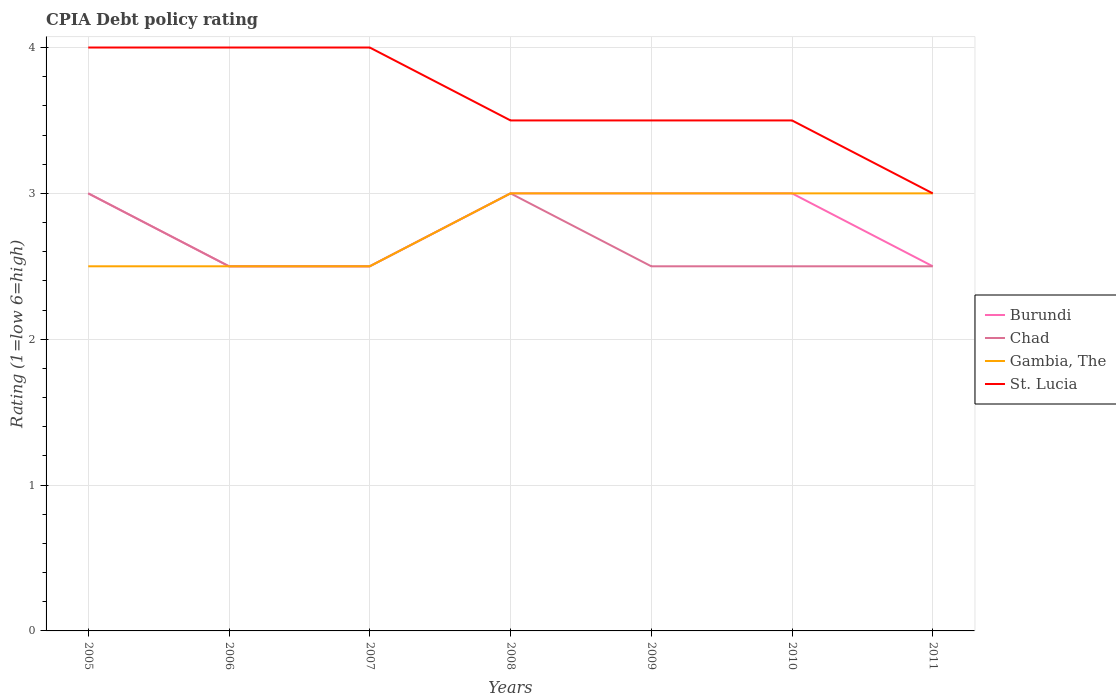How many different coloured lines are there?
Provide a short and direct response. 4. Across all years, what is the maximum CPIA rating in St. Lucia?
Provide a succinct answer. 3. What is the total CPIA rating in Gambia, The in the graph?
Offer a terse response. 0. What is the difference between the highest and the second highest CPIA rating in Burundi?
Your answer should be very brief. 0.5. How many lines are there?
Your response must be concise. 4. How many years are there in the graph?
Provide a succinct answer. 7. Are the values on the major ticks of Y-axis written in scientific E-notation?
Ensure brevity in your answer.  No. Does the graph contain any zero values?
Provide a short and direct response. No. Does the graph contain grids?
Give a very brief answer. Yes. Where does the legend appear in the graph?
Your answer should be compact. Center right. What is the title of the graph?
Give a very brief answer. CPIA Debt policy rating. Does "Cabo Verde" appear as one of the legend labels in the graph?
Provide a succinct answer. No. What is the label or title of the X-axis?
Your answer should be very brief. Years. What is the label or title of the Y-axis?
Offer a terse response. Rating (1=low 6=high). What is the Rating (1=low 6=high) in Burundi in 2005?
Offer a very short reply. 3. What is the Rating (1=low 6=high) in Gambia, The in 2005?
Offer a terse response. 2.5. What is the Rating (1=low 6=high) of Gambia, The in 2006?
Make the answer very short. 2.5. What is the Rating (1=low 6=high) of St. Lucia in 2006?
Offer a terse response. 4. What is the Rating (1=low 6=high) in Burundi in 2007?
Keep it short and to the point. 2.5. What is the Rating (1=low 6=high) in Burundi in 2008?
Offer a terse response. 3. What is the Rating (1=low 6=high) in Chad in 2008?
Ensure brevity in your answer.  3. What is the Rating (1=low 6=high) in Gambia, The in 2008?
Make the answer very short. 3. What is the Rating (1=low 6=high) of Chad in 2009?
Offer a terse response. 2.5. What is the Rating (1=low 6=high) in St. Lucia in 2009?
Offer a very short reply. 3.5. What is the Rating (1=low 6=high) of Burundi in 2010?
Keep it short and to the point. 3. What is the Rating (1=low 6=high) of Chad in 2010?
Your answer should be very brief. 2.5. What is the Rating (1=low 6=high) in Chad in 2011?
Give a very brief answer. 2.5. What is the Rating (1=low 6=high) in St. Lucia in 2011?
Keep it short and to the point. 3. Across all years, what is the maximum Rating (1=low 6=high) in Burundi?
Keep it short and to the point. 3. Across all years, what is the maximum Rating (1=low 6=high) of Gambia, The?
Keep it short and to the point. 3. Across all years, what is the minimum Rating (1=low 6=high) in Burundi?
Keep it short and to the point. 2.5. Across all years, what is the minimum Rating (1=low 6=high) of Chad?
Keep it short and to the point. 2.5. Across all years, what is the minimum Rating (1=low 6=high) in Gambia, The?
Your answer should be compact. 2.5. Across all years, what is the minimum Rating (1=low 6=high) of St. Lucia?
Ensure brevity in your answer.  3. What is the total Rating (1=low 6=high) in Chad in the graph?
Offer a very short reply. 18.5. What is the total Rating (1=low 6=high) of St. Lucia in the graph?
Your answer should be very brief. 25.5. What is the difference between the Rating (1=low 6=high) in St. Lucia in 2005 and that in 2006?
Ensure brevity in your answer.  0. What is the difference between the Rating (1=low 6=high) in Burundi in 2005 and that in 2007?
Give a very brief answer. 0.5. What is the difference between the Rating (1=low 6=high) in Chad in 2005 and that in 2007?
Keep it short and to the point. 0.5. What is the difference between the Rating (1=low 6=high) of Gambia, The in 2005 and that in 2007?
Your answer should be very brief. 0. What is the difference between the Rating (1=low 6=high) in Burundi in 2005 and that in 2008?
Provide a short and direct response. 0. What is the difference between the Rating (1=low 6=high) of Burundi in 2005 and that in 2009?
Your answer should be compact. 0. What is the difference between the Rating (1=low 6=high) in Gambia, The in 2005 and that in 2009?
Keep it short and to the point. -0.5. What is the difference between the Rating (1=low 6=high) in St. Lucia in 2005 and that in 2009?
Ensure brevity in your answer.  0.5. What is the difference between the Rating (1=low 6=high) of Chad in 2005 and that in 2010?
Provide a short and direct response. 0.5. What is the difference between the Rating (1=low 6=high) of Gambia, The in 2005 and that in 2011?
Provide a short and direct response. -0.5. What is the difference between the Rating (1=low 6=high) in St. Lucia in 2005 and that in 2011?
Keep it short and to the point. 1. What is the difference between the Rating (1=low 6=high) of Burundi in 2006 and that in 2007?
Offer a very short reply. 0. What is the difference between the Rating (1=low 6=high) of Gambia, The in 2006 and that in 2007?
Keep it short and to the point. 0. What is the difference between the Rating (1=low 6=high) in St. Lucia in 2006 and that in 2007?
Make the answer very short. 0. What is the difference between the Rating (1=low 6=high) of Burundi in 2006 and that in 2008?
Provide a succinct answer. -0.5. What is the difference between the Rating (1=low 6=high) in Gambia, The in 2006 and that in 2008?
Your answer should be compact. -0.5. What is the difference between the Rating (1=low 6=high) of St. Lucia in 2006 and that in 2008?
Keep it short and to the point. 0.5. What is the difference between the Rating (1=low 6=high) in Burundi in 2006 and that in 2009?
Provide a short and direct response. -0.5. What is the difference between the Rating (1=low 6=high) in Chad in 2006 and that in 2009?
Make the answer very short. 0. What is the difference between the Rating (1=low 6=high) in Gambia, The in 2006 and that in 2009?
Your response must be concise. -0.5. What is the difference between the Rating (1=low 6=high) of St. Lucia in 2006 and that in 2009?
Provide a short and direct response. 0.5. What is the difference between the Rating (1=low 6=high) of Chad in 2006 and that in 2010?
Provide a short and direct response. 0. What is the difference between the Rating (1=low 6=high) of Gambia, The in 2006 and that in 2010?
Your answer should be very brief. -0.5. What is the difference between the Rating (1=low 6=high) in Burundi in 2006 and that in 2011?
Offer a terse response. 0. What is the difference between the Rating (1=low 6=high) in St. Lucia in 2006 and that in 2011?
Make the answer very short. 1. What is the difference between the Rating (1=low 6=high) of Burundi in 2007 and that in 2008?
Provide a succinct answer. -0.5. What is the difference between the Rating (1=low 6=high) in Chad in 2007 and that in 2008?
Give a very brief answer. -0.5. What is the difference between the Rating (1=low 6=high) in Gambia, The in 2007 and that in 2008?
Offer a very short reply. -0.5. What is the difference between the Rating (1=low 6=high) in Burundi in 2007 and that in 2009?
Keep it short and to the point. -0.5. What is the difference between the Rating (1=low 6=high) of Chad in 2007 and that in 2009?
Keep it short and to the point. 0. What is the difference between the Rating (1=low 6=high) of Gambia, The in 2007 and that in 2009?
Keep it short and to the point. -0.5. What is the difference between the Rating (1=low 6=high) in Chad in 2007 and that in 2010?
Make the answer very short. 0. What is the difference between the Rating (1=low 6=high) in St. Lucia in 2007 and that in 2010?
Provide a short and direct response. 0.5. What is the difference between the Rating (1=low 6=high) of Burundi in 2007 and that in 2011?
Your answer should be very brief. 0. What is the difference between the Rating (1=low 6=high) of Gambia, The in 2007 and that in 2011?
Offer a very short reply. -0.5. What is the difference between the Rating (1=low 6=high) in St. Lucia in 2007 and that in 2011?
Your answer should be compact. 1. What is the difference between the Rating (1=low 6=high) of Burundi in 2008 and that in 2009?
Ensure brevity in your answer.  0. What is the difference between the Rating (1=low 6=high) in Chad in 2008 and that in 2009?
Give a very brief answer. 0.5. What is the difference between the Rating (1=low 6=high) of St. Lucia in 2008 and that in 2009?
Offer a terse response. 0. What is the difference between the Rating (1=low 6=high) of Burundi in 2008 and that in 2010?
Offer a very short reply. 0. What is the difference between the Rating (1=low 6=high) in Gambia, The in 2008 and that in 2010?
Your response must be concise. 0. What is the difference between the Rating (1=low 6=high) of St. Lucia in 2008 and that in 2010?
Offer a terse response. 0. What is the difference between the Rating (1=low 6=high) in Burundi in 2008 and that in 2011?
Provide a short and direct response. 0.5. What is the difference between the Rating (1=low 6=high) in Chad in 2008 and that in 2011?
Give a very brief answer. 0.5. What is the difference between the Rating (1=low 6=high) of Gambia, The in 2008 and that in 2011?
Provide a succinct answer. 0. What is the difference between the Rating (1=low 6=high) in St. Lucia in 2008 and that in 2011?
Give a very brief answer. 0.5. What is the difference between the Rating (1=low 6=high) of Chad in 2009 and that in 2010?
Provide a succinct answer. 0. What is the difference between the Rating (1=low 6=high) of St. Lucia in 2009 and that in 2010?
Give a very brief answer. 0. What is the difference between the Rating (1=low 6=high) of Chad in 2009 and that in 2011?
Give a very brief answer. 0. What is the difference between the Rating (1=low 6=high) in Chad in 2010 and that in 2011?
Ensure brevity in your answer.  0. What is the difference between the Rating (1=low 6=high) of Gambia, The in 2010 and that in 2011?
Keep it short and to the point. 0. What is the difference between the Rating (1=low 6=high) of Burundi in 2005 and the Rating (1=low 6=high) of Gambia, The in 2006?
Provide a short and direct response. 0.5. What is the difference between the Rating (1=low 6=high) in Burundi in 2005 and the Rating (1=low 6=high) in St. Lucia in 2006?
Make the answer very short. -1. What is the difference between the Rating (1=low 6=high) of Chad in 2005 and the Rating (1=low 6=high) of Gambia, The in 2006?
Give a very brief answer. 0.5. What is the difference between the Rating (1=low 6=high) in Chad in 2005 and the Rating (1=low 6=high) in St. Lucia in 2006?
Your response must be concise. -1. What is the difference between the Rating (1=low 6=high) of Burundi in 2005 and the Rating (1=low 6=high) of Chad in 2007?
Your answer should be very brief. 0.5. What is the difference between the Rating (1=low 6=high) in Burundi in 2005 and the Rating (1=low 6=high) in Gambia, The in 2007?
Ensure brevity in your answer.  0.5. What is the difference between the Rating (1=low 6=high) of Burundi in 2005 and the Rating (1=low 6=high) of St. Lucia in 2007?
Keep it short and to the point. -1. What is the difference between the Rating (1=low 6=high) in Chad in 2005 and the Rating (1=low 6=high) in St. Lucia in 2007?
Your answer should be compact. -1. What is the difference between the Rating (1=low 6=high) of Gambia, The in 2005 and the Rating (1=low 6=high) of St. Lucia in 2007?
Your response must be concise. -1.5. What is the difference between the Rating (1=low 6=high) in Burundi in 2005 and the Rating (1=low 6=high) in Gambia, The in 2008?
Offer a very short reply. 0. What is the difference between the Rating (1=low 6=high) in Burundi in 2005 and the Rating (1=low 6=high) in St. Lucia in 2008?
Keep it short and to the point. -0.5. What is the difference between the Rating (1=low 6=high) of Gambia, The in 2005 and the Rating (1=low 6=high) of St. Lucia in 2008?
Give a very brief answer. -1. What is the difference between the Rating (1=low 6=high) in Burundi in 2005 and the Rating (1=low 6=high) in Chad in 2009?
Ensure brevity in your answer.  0.5. What is the difference between the Rating (1=low 6=high) of Burundi in 2005 and the Rating (1=low 6=high) of St. Lucia in 2009?
Offer a very short reply. -0.5. What is the difference between the Rating (1=low 6=high) of Chad in 2005 and the Rating (1=low 6=high) of Gambia, The in 2009?
Your answer should be very brief. 0. What is the difference between the Rating (1=low 6=high) of Chad in 2005 and the Rating (1=low 6=high) of St. Lucia in 2009?
Your answer should be compact. -0.5. What is the difference between the Rating (1=low 6=high) of Burundi in 2005 and the Rating (1=low 6=high) of Chad in 2010?
Keep it short and to the point. 0.5. What is the difference between the Rating (1=low 6=high) of Burundi in 2006 and the Rating (1=low 6=high) of Chad in 2007?
Provide a succinct answer. 0. What is the difference between the Rating (1=low 6=high) of Burundi in 2006 and the Rating (1=low 6=high) of Chad in 2008?
Provide a succinct answer. -0.5. What is the difference between the Rating (1=low 6=high) of Burundi in 2006 and the Rating (1=low 6=high) of Gambia, The in 2008?
Your response must be concise. -0.5. What is the difference between the Rating (1=low 6=high) of Chad in 2006 and the Rating (1=low 6=high) of St. Lucia in 2008?
Make the answer very short. -1. What is the difference between the Rating (1=low 6=high) of Gambia, The in 2006 and the Rating (1=low 6=high) of St. Lucia in 2008?
Provide a succinct answer. -1. What is the difference between the Rating (1=low 6=high) in Burundi in 2006 and the Rating (1=low 6=high) in Gambia, The in 2009?
Provide a succinct answer. -0.5. What is the difference between the Rating (1=low 6=high) in Chad in 2006 and the Rating (1=low 6=high) in Gambia, The in 2009?
Your answer should be compact. -0.5. What is the difference between the Rating (1=low 6=high) in Chad in 2006 and the Rating (1=low 6=high) in St. Lucia in 2010?
Make the answer very short. -1. What is the difference between the Rating (1=low 6=high) of Gambia, The in 2006 and the Rating (1=low 6=high) of St. Lucia in 2010?
Make the answer very short. -1. What is the difference between the Rating (1=low 6=high) in Burundi in 2006 and the Rating (1=low 6=high) in St. Lucia in 2011?
Ensure brevity in your answer.  -0.5. What is the difference between the Rating (1=low 6=high) of Chad in 2006 and the Rating (1=low 6=high) of Gambia, The in 2011?
Offer a very short reply. -0.5. What is the difference between the Rating (1=low 6=high) of Chad in 2006 and the Rating (1=low 6=high) of St. Lucia in 2011?
Provide a succinct answer. -0.5. What is the difference between the Rating (1=low 6=high) in Burundi in 2007 and the Rating (1=low 6=high) in Chad in 2008?
Your answer should be compact. -0.5. What is the difference between the Rating (1=low 6=high) in Burundi in 2007 and the Rating (1=low 6=high) in Gambia, The in 2008?
Your response must be concise. -0.5. What is the difference between the Rating (1=low 6=high) of Burundi in 2007 and the Rating (1=low 6=high) of St. Lucia in 2008?
Offer a terse response. -1. What is the difference between the Rating (1=low 6=high) of Chad in 2007 and the Rating (1=low 6=high) of St. Lucia in 2008?
Give a very brief answer. -1. What is the difference between the Rating (1=low 6=high) in Gambia, The in 2007 and the Rating (1=low 6=high) in St. Lucia in 2008?
Ensure brevity in your answer.  -1. What is the difference between the Rating (1=low 6=high) of Burundi in 2007 and the Rating (1=low 6=high) of Chad in 2009?
Ensure brevity in your answer.  0. What is the difference between the Rating (1=low 6=high) in Burundi in 2007 and the Rating (1=low 6=high) in St. Lucia in 2009?
Your answer should be very brief. -1. What is the difference between the Rating (1=low 6=high) in Chad in 2007 and the Rating (1=low 6=high) in Gambia, The in 2009?
Give a very brief answer. -0.5. What is the difference between the Rating (1=low 6=high) of Chad in 2007 and the Rating (1=low 6=high) of St. Lucia in 2009?
Keep it short and to the point. -1. What is the difference between the Rating (1=low 6=high) of Burundi in 2007 and the Rating (1=low 6=high) of Chad in 2010?
Make the answer very short. 0. What is the difference between the Rating (1=low 6=high) of Chad in 2007 and the Rating (1=low 6=high) of Gambia, The in 2010?
Give a very brief answer. -0.5. What is the difference between the Rating (1=low 6=high) of Chad in 2007 and the Rating (1=low 6=high) of St. Lucia in 2010?
Ensure brevity in your answer.  -1. What is the difference between the Rating (1=low 6=high) in Gambia, The in 2007 and the Rating (1=low 6=high) in St. Lucia in 2010?
Ensure brevity in your answer.  -1. What is the difference between the Rating (1=low 6=high) in Burundi in 2007 and the Rating (1=low 6=high) in Chad in 2011?
Your answer should be compact. 0. What is the difference between the Rating (1=low 6=high) of Chad in 2007 and the Rating (1=low 6=high) of St. Lucia in 2011?
Give a very brief answer. -0.5. What is the difference between the Rating (1=low 6=high) in Gambia, The in 2007 and the Rating (1=low 6=high) in St. Lucia in 2011?
Offer a terse response. -0.5. What is the difference between the Rating (1=low 6=high) of Burundi in 2008 and the Rating (1=low 6=high) of Gambia, The in 2009?
Provide a succinct answer. 0. What is the difference between the Rating (1=low 6=high) in Burundi in 2008 and the Rating (1=low 6=high) in St. Lucia in 2010?
Offer a terse response. -0.5. What is the difference between the Rating (1=low 6=high) in Gambia, The in 2008 and the Rating (1=low 6=high) in St. Lucia in 2010?
Offer a very short reply. -0.5. What is the difference between the Rating (1=low 6=high) in Burundi in 2008 and the Rating (1=low 6=high) in St. Lucia in 2011?
Your answer should be very brief. 0. What is the difference between the Rating (1=low 6=high) in Chad in 2008 and the Rating (1=low 6=high) in St. Lucia in 2011?
Provide a succinct answer. 0. What is the difference between the Rating (1=low 6=high) in Burundi in 2009 and the Rating (1=low 6=high) in Chad in 2010?
Make the answer very short. 0.5. What is the difference between the Rating (1=low 6=high) in Burundi in 2009 and the Rating (1=low 6=high) in Gambia, The in 2010?
Provide a succinct answer. 0. What is the difference between the Rating (1=low 6=high) in Burundi in 2009 and the Rating (1=low 6=high) in St. Lucia in 2010?
Provide a succinct answer. -0.5. What is the difference between the Rating (1=low 6=high) in Chad in 2009 and the Rating (1=low 6=high) in St. Lucia in 2010?
Your answer should be compact. -1. What is the difference between the Rating (1=low 6=high) in Burundi in 2009 and the Rating (1=low 6=high) in Chad in 2011?
Your answer should be compact. 0.5. What is the difference between the Rating (1=low 6=high) in Burundi in 2009 and the Rating (1=low 6=high) in St. Lucia in 2011?
Make the answer very short. 0. What is the difference between the Rating (1=low 6=high) of Chad in 2009 and the Rating (1=low 6=high) of Gambia, The in 2011?
Make the answer very short. -0.5. What is the difference between the Rating (1=low 6=high) in Burundi in 2010 and the Rating (1=low 6=high) in Chad in 2011?
Your answer should be very brief. 0.5. What is the difference between the Rating (1=low 6=high) in Burundi in 2010 and the Rating (1=low 6=high) in St. Lucia in 2011?
Provide a succinct answer. 0. What is the difference between the Rating (1=low 6=high) in Chad in 2010 and the Rating (1=low 6=high) in St. Lucia in 2011?
Keep it short and to the point. -0.5. What is the difference between the Rating (1=low 6=high) of Gambia, The in 2010 and the Rating (1=low 6=high) of St. Lucia in 2011?
Offer a very short reply. 0. What is the average Rating (1=low 6=high) in Burundi per year?
Your answer should be very brief. 2.79. What is the average Rating (1=low 6=high) in Chad per year?
Your answer should be compact. 2.64. What is the average Rating (1=low 6=high) in Gambia, The per year?
Your answer should be compact. 2.79. What is the average Rating (1=low 6=high) in St. Lucia per year?
Provide a short and direct response. 3.64. In the year 2005, what is the difference between the Rating (1=low 6=high) of Chad and Rating (1=low 6=high) of Gambia, The?
Offer a terse response. 0.5. In the year 2006, what is the difference between the Rating (1=low 6=high) in Burundi and Rating (1=low 6=high) in Gambia, The?
Provide a short and direct response. 0. In the year 2006, what is the difference between the Rating (1=low 6=high) in Chad and Rating (1=low 6=high) in Gambia, The?
Provide a short and direct response. 0. In the year 2006, what is the difference between the Rating (1=low 6=high) in Chad and Rating (1=low 6=high) in St. Lucia?
Your answer should be very brief. -1.5. In the year 2007, what is the difference between the Rating (1=low 6=high) of Burundi and Rating (1=low 6=high) of Chad?
Offer a very short reply. 0. In the year 2007, what is the difference between the Rating (1=low 6=high) in Burundi and Rating (1=low 6=high) in Gambia, The?
Your response must be concise. 0. In the year 2007, what is the difference between the Rating (1=low 6=high) in Burundi and Rating (1=low 6=high) in St. Lucia?
Give a very brief answer. -1.5. In the year 2007, what is the difference between the Rating (1=low 6=high) in Chad and Rating (1=low 6=high) in St. Lucia?
Your answer should be very brief. -1.5. In the year 2007, what is the difference between the Rating (1=low 6=high) of Gambia, The and Rating (1=low 6=high) of St. Lucia?
Make the answer very short. -1.5. In the year 2008, what is the difference between the Rating (1=low 6=high) in Burundi and Rating (1=low 6=high) in Chad?
Ensure brevity in your answer.  0. In the year 2008, what is the difference between the Rating (1=low 6=high) of Burundi and Rating (1=low 6=high) of St. Lucia?
Your response must be concise. -0.5. In the year 2008, what is the difference between the Rating (1=low 6=high) of Chad and Rating (1=low 6=high) of Gambia, The?
Your response must be concise. 0. In the year 2008, what is the difference between the Rating (1=low 6=high) of Chad and Rating (1=low 6=high) of St. Lucia?
Your response must be concise. -0.5. In the year 2010, what is the difference between the Rating (1=low 6=high) of Burundi and Rating (1=low 6=high) of Chad?
Your answer should be compact. 0.5. In the year 2010, what is the difference between the Rating (1=low 6=high) of Chad and Rating (1=low 6=high) of Gambia, The?
Your answer should be very brief. -0.5. In the year 2010, what is the difference between the Rating (1=low 6=high) in Chad and Rating (1=low 6=high) in St. Lucia?
Offer a very short reply. -1. In the year 2011, what is the difference between the Rating (1=low 6=high) in Burundi and Rating (1=low 6=high) in Chad?
Your response must be concise. 0. In the year 2011, what is the difference between the Rating (1=low 6=high) in Burundi and Rating (1=low 6=high) in St. Lucia?
Your answer should be very brief. -0.5. In the year 2011, what is the difference between the Rating (1=low 6=high) of Chad and Rating (1=low 6=high) of Gambia, The?
Your answer should be very brief. -0.5. In the year 2011, what is the difference between the Rating (1=low 6=high) of Chad and Rating (1=low 6=high) of St. Lucia?
Keep it short and to the point. -0.5. What is the ratio of the Rating (1=low 6=high) of Burundi in 2005 to that in 2006?
Provide a short and direct response. 1.2. What is the ratio of the Rating (1=low 6=high) of Burundi in 2005 to that in 2007?
Your answer should be compact. 1.2. What is the ratio of the Rating (1=low 6=high) in Chad in 2005 to that in 2007?
Your response must be concise. 1.2. What is the ratio of the Rating (1=low 6=high) in Gambia, The in 2005 to that in 2007?
Make the answer very short. 1. What is the ratio of the Rating (1=low 6=high) in St. Lucia in 2005 to that in 2007?
Make the answer very short. 1. What is the ratio of the Rating (1=low 6=high) in Burundi in 2005 to that in 2008?
Make the answer very short. 1. What is the ratio of the Rating (1=low 6=high) of Gambia, The in 2005 to that in 2008?
Give a very brief answer. 0.83. What is the ratio of the Rating (1=low 6=high) of Burundi in 2005 to that in 2009?
Give a very brief answer. 1. What is the ratio of the Rating (1=low 6=high) of Gambia, The in 2005 to that in 2009?
Your response must be concise. 0.83. What is the ratio of the Rating (1=low 6=high) in St. Lucia in 2005 to that in 2009?
Make the answer very short. 1.14. What is the ratio of the Rating (1=low 6=high) of Chad in 2005 to that in 2010?
Your answer should be very brief. 1.2. What is the ratio of the Rating (1=low 6=high) of Gambia, The in 2005 to that in 2010?
Your answer should be very brief. 0.83. What is the ratio of the Rating (1=low 6=high) of St. Lucia in 2005 to that in 2010?
Keep it short and to the point. 1.14. What is the ratio of the Rating (1=low 6=high) in Burundi in 2005 to that in 2011?
Your answer should be very brief. 1.2. What is the ratio of the Rating (1=low 6=high) in Gambia, The in 2006 to that in 2007?
Offer a very short reply. 1. What is the ratio of the Rating (1=low 6=high) of St. Lucia in 2006 to that in 2007?
Your answer should be compact. 1. What is the ratio of the Rating (1=low 6=high) in Burundi in 2006 to that in 2008?
Keep it short and to the point. 0.83. What is the ratio of the Rating (1=low 6=high) in Gambia, The in 2006 to that in 2008?
Keep it short and to the point. 0.83. What is the ratio of the Rating (1=low 6=high) in Burundi in 2006 to that in 2009?
Your answer should be very brief. 0.83. What is the ratio of the Rating (1=low 6=high) of Chad in 2006 to that in 2009?
Provide a short and direct response. 1. What is the ratio of the Rating (1=low 6=high) in Gambia, The in 2006 to that in 2009?
Your response must be concise. 0.83. What is the ratio of the Rating (1=low 6=high) of St. Lucia in 2006 to that in 2009?
Offer a terse response. 1.14. What is the ratio of the Rating (1=low 6=high) of Burundi in 2006 to that in 2010?
Ensure brevity in your answer.  0.83. What is the ratio of the Rating (1=low 6=high) in St. Lucia in 2006 to that in 2010?
Make the answer very short. 1.14. What is the ratio of the Rating (1=low 6=high) of Burundi in 2006 to that in 2011?
Provide a short and direct response. 1. What is the ratio of the Rating (1=low 6=high) in St. Lucia in 2006 to that in 2011?
Make the answer very short. 1.33. What is the ratio of the Rating (1=low 6=high) in Burundi in 2007 to that in 2008?
Make the answer very short. 0.83. What is the ratio of the Rating (1=low 6=high) of Gambia, The in 2007 to that in 2008?
Make the answer very short. 0.83. What is the ratio of the Rating (1=low 6=high) of St. Lucia in 2007 to that in 2008?
Ensure brevity in your answer.  1.14. What is the ratio of the Rating (1=low 6=high) in Chad in 2007 to that in 2009?
Your answer should be very brief. 1. What is the ratio of the Rating (1=low 6=high) in St. Lucia in 2007 to that in 2009?
Keep it short and to the point. 1.14. What is the ratio of the Rating (1=low 6=high) of Burundi in 2007 to that in 2010?
Offer a very short reply. 0.83. What is the ratio of the Rating (1=low 6=high) of Chad in 2007 to that in 2010?
Your response must be concise. 1. What is the ratio of the Rating (1=low 6=high) of Gambia, The in 2007 to that in 2010?
Keep it short and to the point. 0.83. What is the ratio of the Rating (1=low 6=high) of St. Lucia in 2007 to that in 2010?
Give a very brief answer. 1.14. What is the ratio of the Rating (1=low 6=high) of Gambia, The in 2007 to that in 2011?
Make the answer very short. 0.83. What is the ratio of the Rating (1=low 6=high) of Burundi in 2008 to that in 2009?
Your answer should be compact. 1. What is the ratio of the Rating (1=low 6=high) in Chad in 2008 to that in 2009?
Your answer should be compact. 1.2. What is the ratio of the Rating (1=low 6=high) in Gambia, The in 2008 to that in 2009?
Offer a very short reply. 1. What is the ratio of the Rating (1=low 6=high) in St. Lucia in 2008 to that in 2009?
Make the answer very short. 1. What is the ratio of the Rating (1=low 6=high) in Burundi in 2008 to that in 2010?
Your answer should be compact. 1. What is the ratio of the Rating (1=low 6=high) of Chad in 2008 to that in 2011?
Your answer should be compact. 1.2. What is the ratio of the Rating (1=low 6=high) of Burundi in 2009 to that in 2010?
Give a very brief answer. 1. What is the ratio of the Rating (1=low 6=high) in Chad in 2009 to that in 2010?
Provide a short and direct response. 1. What is the ratio of the Rating (1=low 6=high) in Gambia, The in 2009 to that in 2010?
Your response must be concise. 1. What is the ratio of the Rating (1=low 6=high) in St. Lucia in 2009 to that in 2010?
Offer a very short reply. 1. What is the ratio of the Rating (1=low 6=high) of Chad in 2009 to that in 2011?
Your response must be concise. 1. What is the ratio of the Rating (1=low 6=high) in Gambia, The in 2009 to that in 2011?
Provide a succinct answer. 1. What is the ratio of the Rating (1=low 6=high) in Gambia, The in 2010 to that in 2011?
Offer a very short reply. 1. What is the ratio of the Rating (1=low 6=high) in St. Lucia in 2010 to that in 2011?
Keep it short and to the point. 1.17. What is the difference between the highest and the lowest Rating (1=low 6=high) of Burundi?
Your answer should be very brief. 0.5. What is the difference between the highest and the lowest Rating (1=low 6=high) of Gambia, The?
Your response must be concise. 0.5. What is the difference between the highest and the lowest Rating (1=low 6=high) in St. Lucia?
Your response must be concise. 1. 